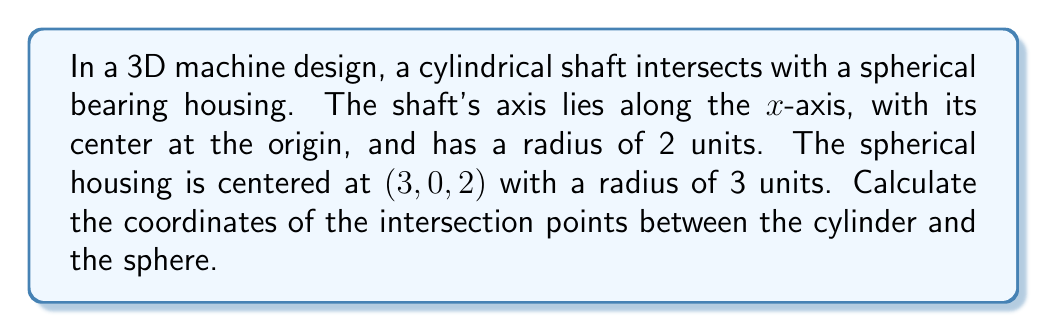Provide a solution to this math problem. Let's approach this step-by-step:

1) The equation of the cylindrical shaft:
   $$y^2 + z^2 = 4$$

2) The equation of the spherical housing:
   $$(x-3)^2 + y^2 + (z-2)^2 = 9$$

3) To find the intersection, we need to solve these equations simultaneously. Substitute the cylinder equation into the sphere equation:

   $$(x-3)^2 + 4 + (z-2)^2 = 9$$

4) Simplify:
   $$x^2 - 6x + 9 + 4 + z^2 - 4z + 4 = 9$$
   $$x^2 - 6x + z^2 - 4z + 8 = 0$$

5) Complete the square for both x and z terms:
   $$(x^2 - 6x + 9) + (z^2 - 4z + 4) = 5$$
   $$(x - 3)^2 + (z - 2)^2 = 5$$

6) This is the equation of a circle in the xz-plane. To find y, use the cylinder equation:
   $$y = \pm\sqrt{4 - z^2}$$

7) The circle equation in parametric form (with parameter t):
   $$x = 3 + \sqrt{5}\cos(t)$$
   $$z = 2 + \sqrt{5}\sin(t)$$

8) Solve for t when y = 0 (top and bottom intersection points):
   $$4 - z^2 = 0$$
   $$z = \pm 2$$

   When $z = 2$, $\sin(t) = 0$, so $t = 0$
   When $z = -2$, $\sin(t) = -\frac{2}{\sqrt{5}}$, so $t = \arcsin(-\frac{2}{\sqrt{5}})$

9) Calculate x for these t values:
   When $t = 0$, $x = 3 + \sqrt{5}$
   When $t = \arcsin(-\frac{2}{\sqrt{5}})$, $x = 3 + \sqrt{5}\cos(\arcsin(-\frac{2}{\sqrt{5}})) = 3 + 1 = 4$

Therefore, the intersection points are:
$$(3 + \sqrt{5}, 0, 2), (3 + \sqrt{5}, 0, -2), (4, \pm\sqrt{3}, 0)$$
Answer: $$(3 + \sqrt{5}, 0, 2), (3 + \sqrt{5}, 0, -2), (4, \pm\sqrt{3}, 0)$$ 